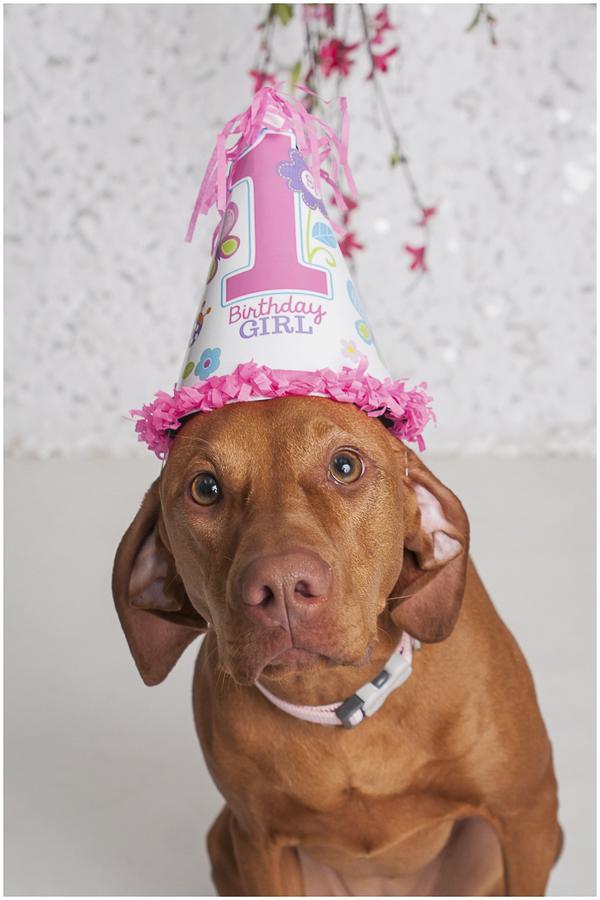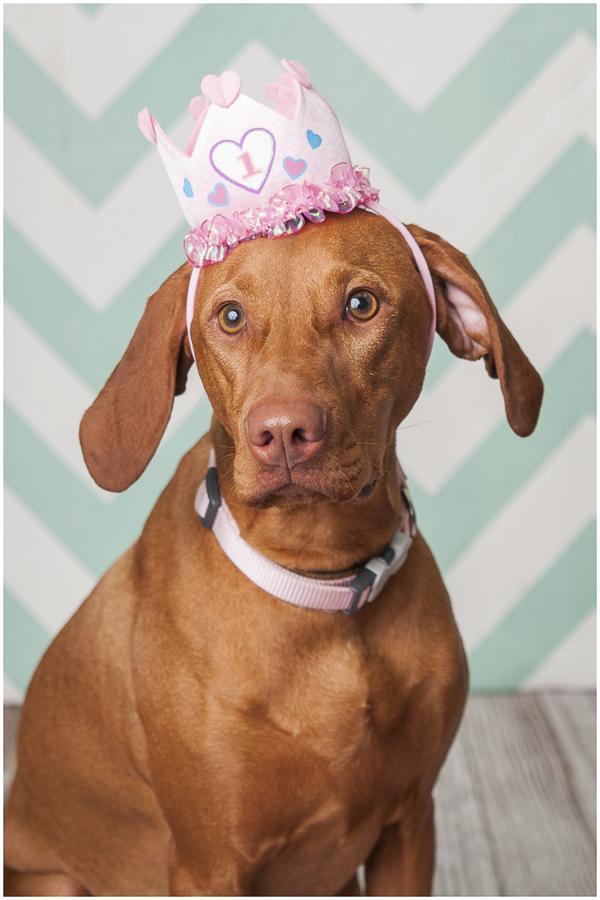The first image is the image on the left, the second image is the image on the right. Given the left and right images, does the statement "At least one of the images has a cake in front of the dog." hold true? Answer yes or no. No. 